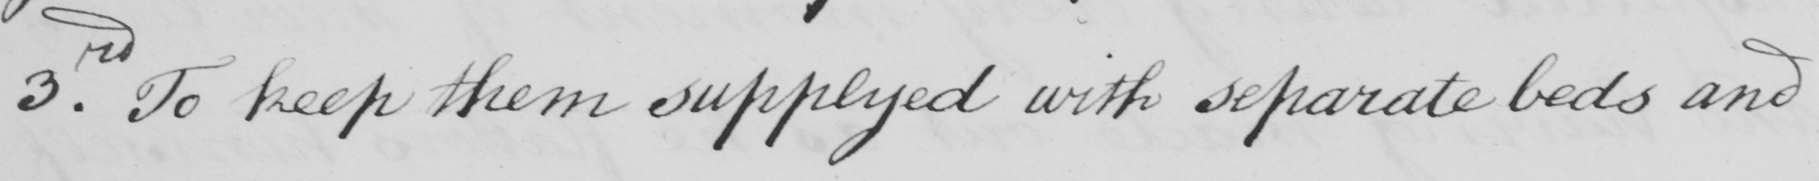Please provide the text content of this handwritten line. 3rd. To keep them supplyed with separate beds and 